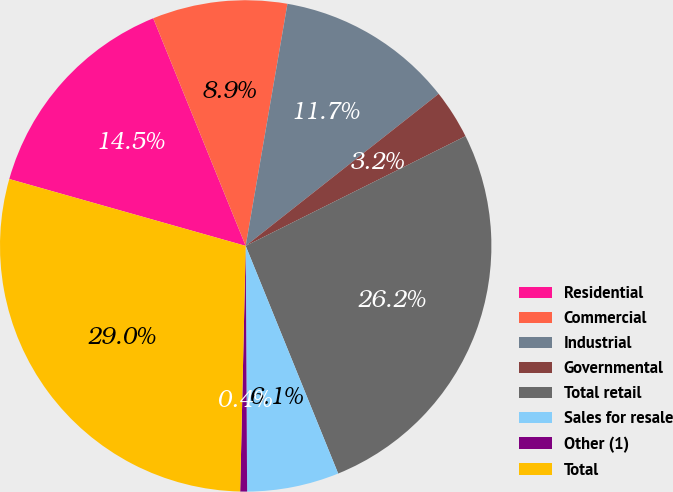Convert chart to OTSL. <chart><loc_0><loc_0><loc_500><loc_500><pie_chart><fcel>Residential<fcel>Commercial<fcel>Industrial<fcel>Governmental<fcel>Total retail<fcel>Sales for resale<fcel>Other (1)<fcel>Total<nl><fcel>14.47%<fcel>8.86%<fcel>11.66%<fcel>3.25%<fcel>26.23%<fcel>6.05%<fcel>0.45%<fcel>29.03%<nl></chart> 